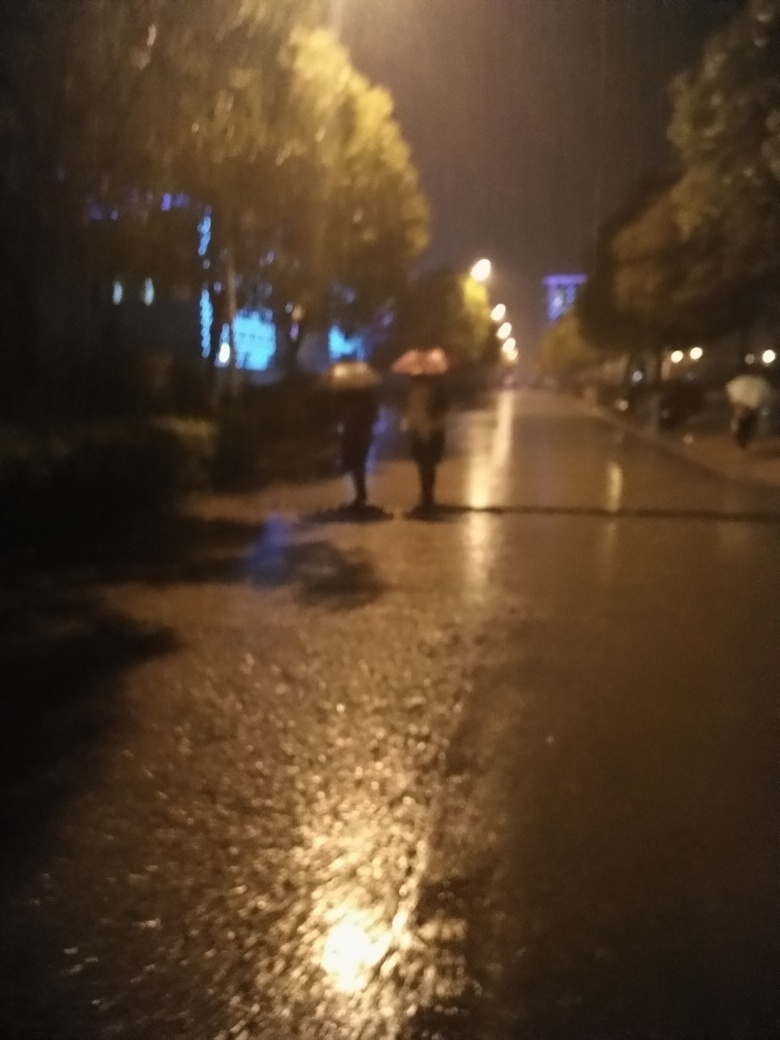What can you tell me about the environment captured in this image? The image appears to capture an outdoor evening scene under rainy conditions, as indicated by the reflections on the wet pavement and the presence of umbrellas. It seems like an urban setting with street lights providing the main source of illumination, imparting a moody atmosphere to the picture. 